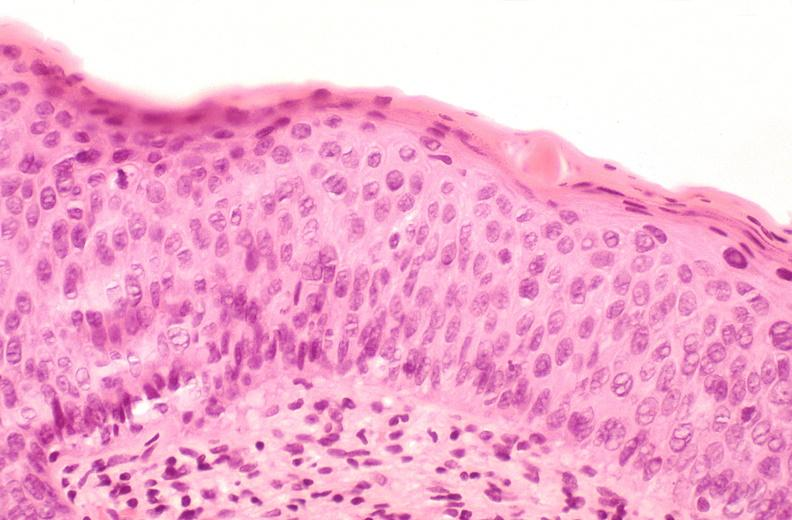s adrenal of premature 30 week gestation gram infant lesion present?
Answer the question using a single word or phrase. No 